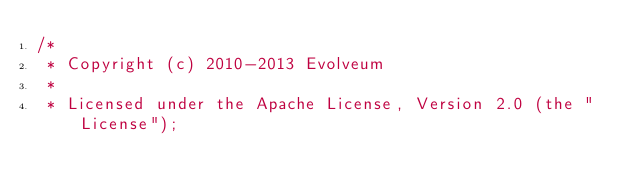Convert code to text. <code><loc_0><loc_0><loc_500><loc_500><_Java_>/*
 * Copyright (c) 2010-2013 Evolveum
 *
 * Licensed under the Apache License, Version 2.0 (the "License");</code> 